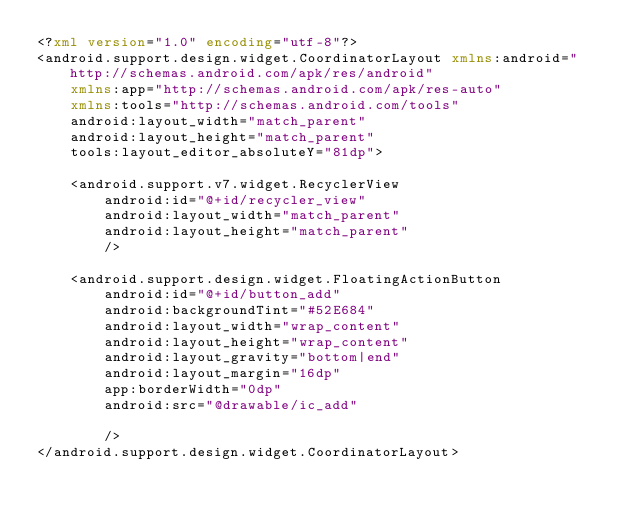<code> <loc_0><loc_0><loc_500><loc_500><_XML_><?xml version="1.0" encoding="utf-8"?>
<android.support.design.widget.CoordinatorLayout xmlns:android="http://schemas.android.com/apk/res/android"
    xmlns:app="http://schemas.android.com/apk/res-auto"
    xmlns:tools="http://schemas.android.com/tools"
    android:layout_width="match_parent"
    android:layout_height="match_parent"
    tools:layout_editor_absoluteY="81dp">

    <android.support.v7.widget.RecyclerView
        android:id="@+id/recycler_view"
        android:layout_width="match_parent"
        android:layout_height="match_parent"
        />
    
    <android.support.design.widget.FloatingActionButton
        android:id="@+id/button_add"
        android:backgroundTint="#52E684"
        android:layout_width="wrap_content"
        android:layout_height="wrap_content"
        android:layout_gravity="bottom|end"
        android:layout_margin="16dp"
        app:borderWidth="0dp"
        android:src="@drawable/ic_add"

        />
</android.support.design.widget.CoordinatorLayout></code> 